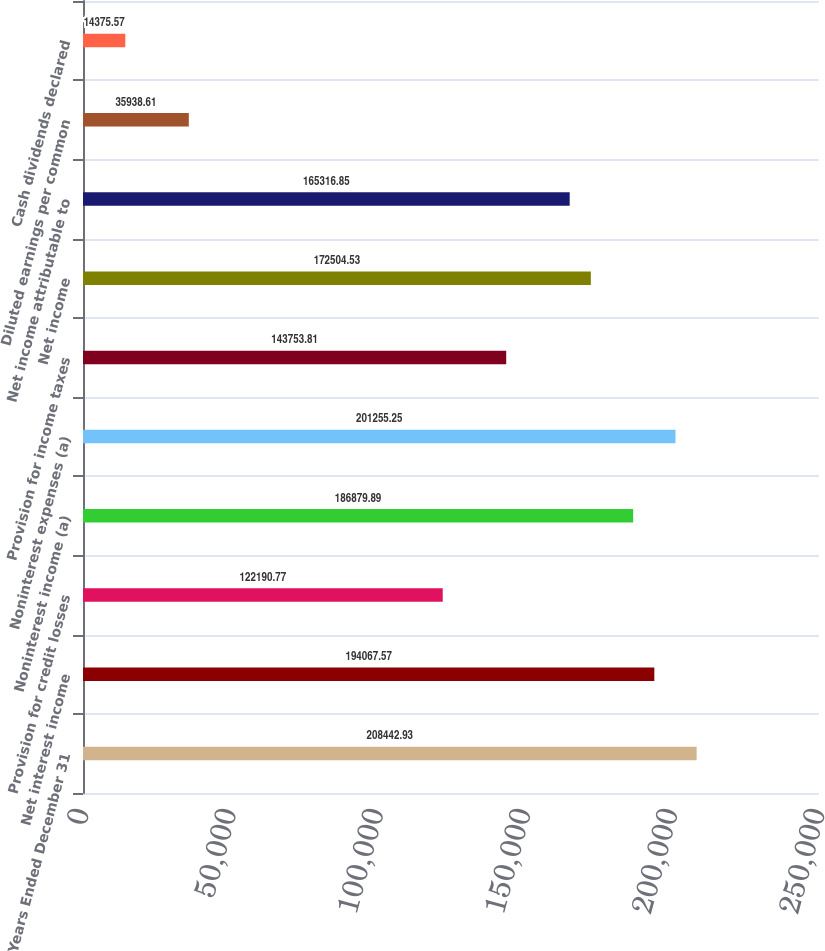Convert chart to OTSL. <chart><loc_0><loc_0><loc_500><loc_500><bar_chart><fcel>Years Ended December 31<fcel>Net interest income<fcel>Provision for credit losses<fcel>Noninterest income (a)<fcel>Noninterest expenses (a)<fcel>Provision for income taxes<fcel>Net income<fcel>Net income attributable to<fcel>Diluted earnings per common<fcel>Cash dividends declared<nl><fcel>208443<fcel>194068<fcel>122191<fcel>186880<fcel>201255<fcel>143754<fcel>172505<fcel>165317<fcel>35938.6<fcel>14375.6<nl></chart> 